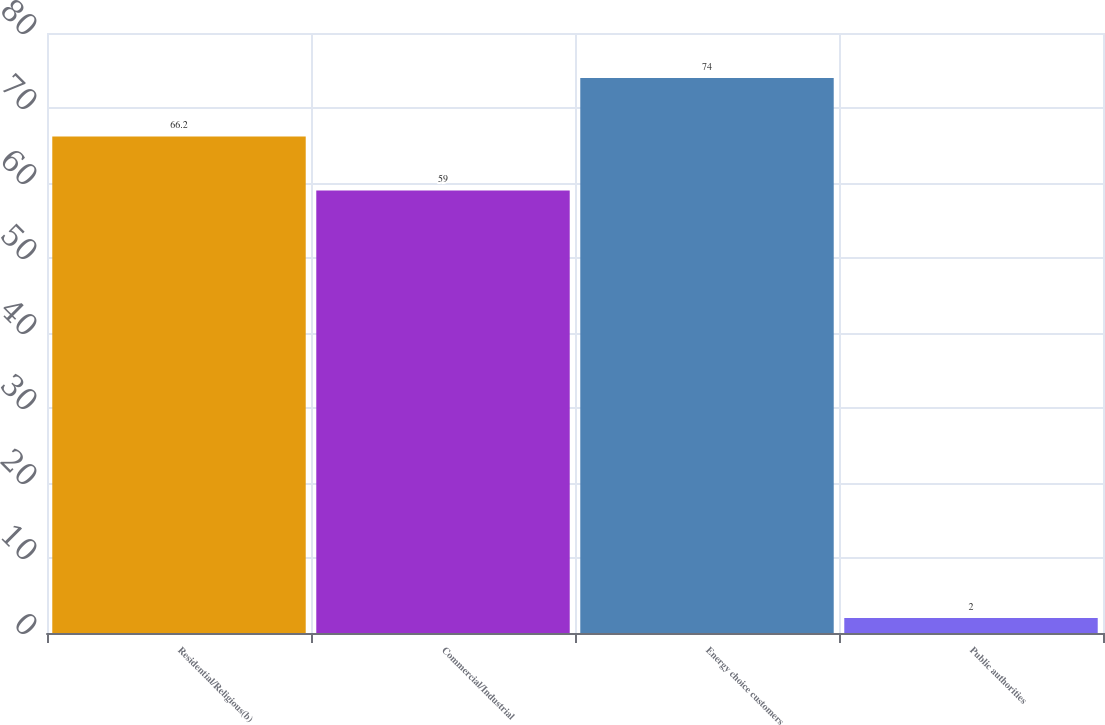Convert chart. <chart><loc_0><loc_0><loc_500><loc_500><bar_chart><fcel>Residential/Religious(b)<fcel>Commercial/Industrial<fcel>Energy choice customers<fcel>Public authorities<nl><fcel>66.2<fcel>59<fcel>74<fcel>2<nl></chart> 